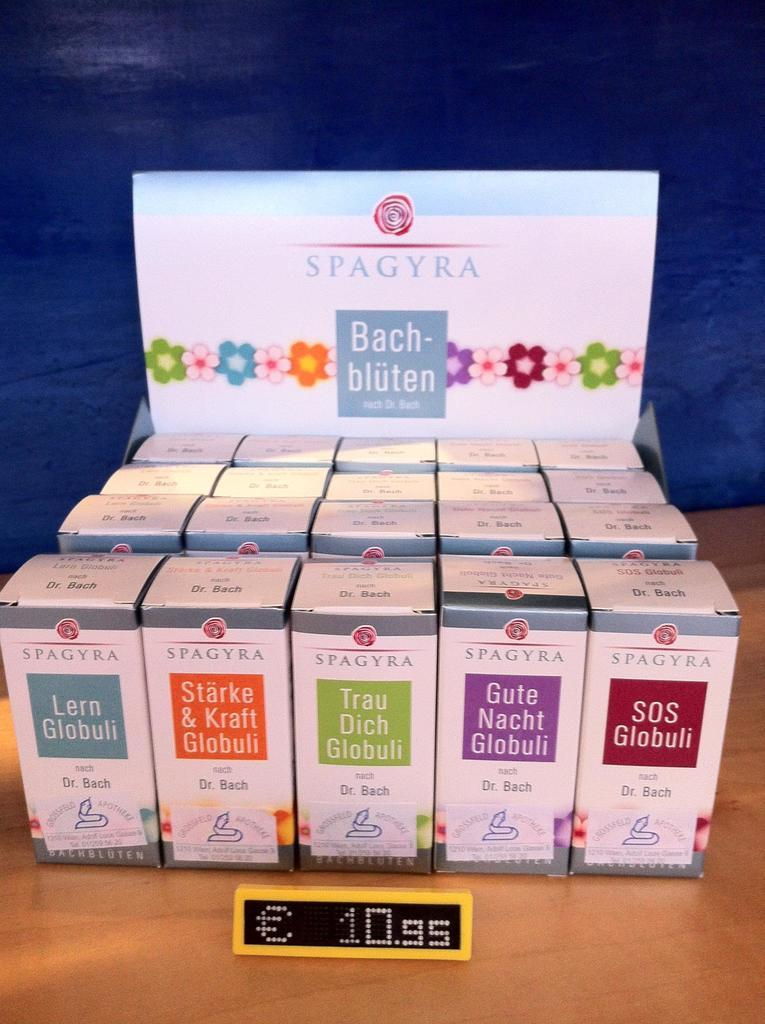Provide a one-sentence caption for the provided image. A bunch of boxes  from Spagyra with a foreigner language on the front. 